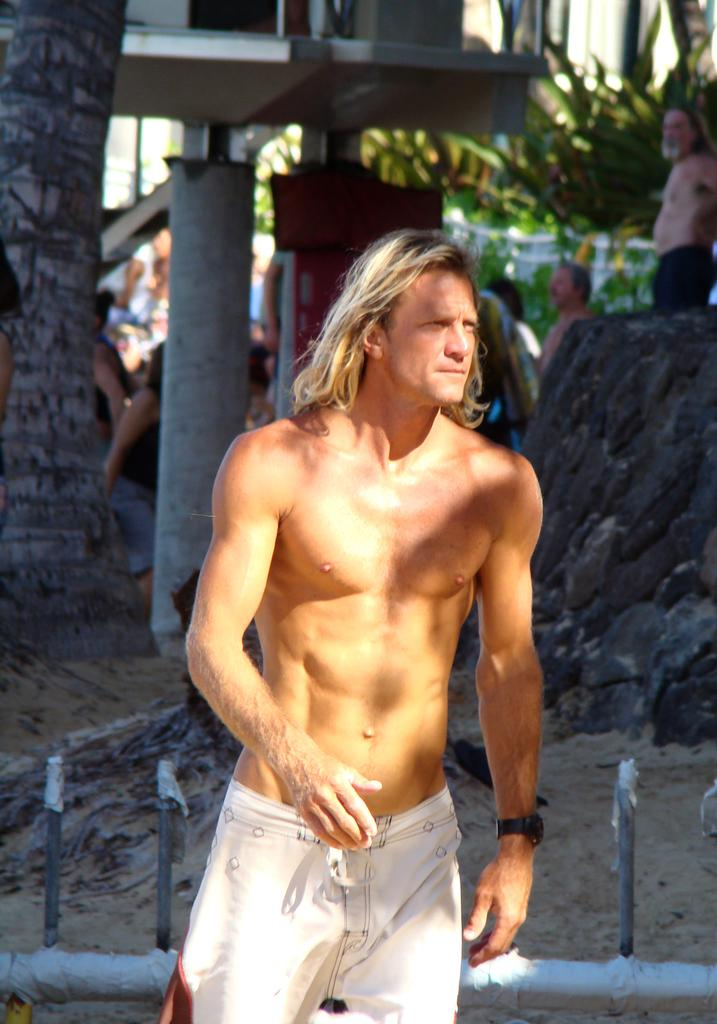Who or what is the main subject in the center of the image? There is a person in the center of the image. What can be seen in the background of the image? There is a tree trunk in the background of the image. How many people are present in the image? There are people in the image, but the exact number is not specified. What type of vegetation is present in the image? There are plants in the image. What type of cord is being used to hold the clocks in the image? There is no mention of clocks or cords in the image; it features a person, a tree trunk, people, and plants. 